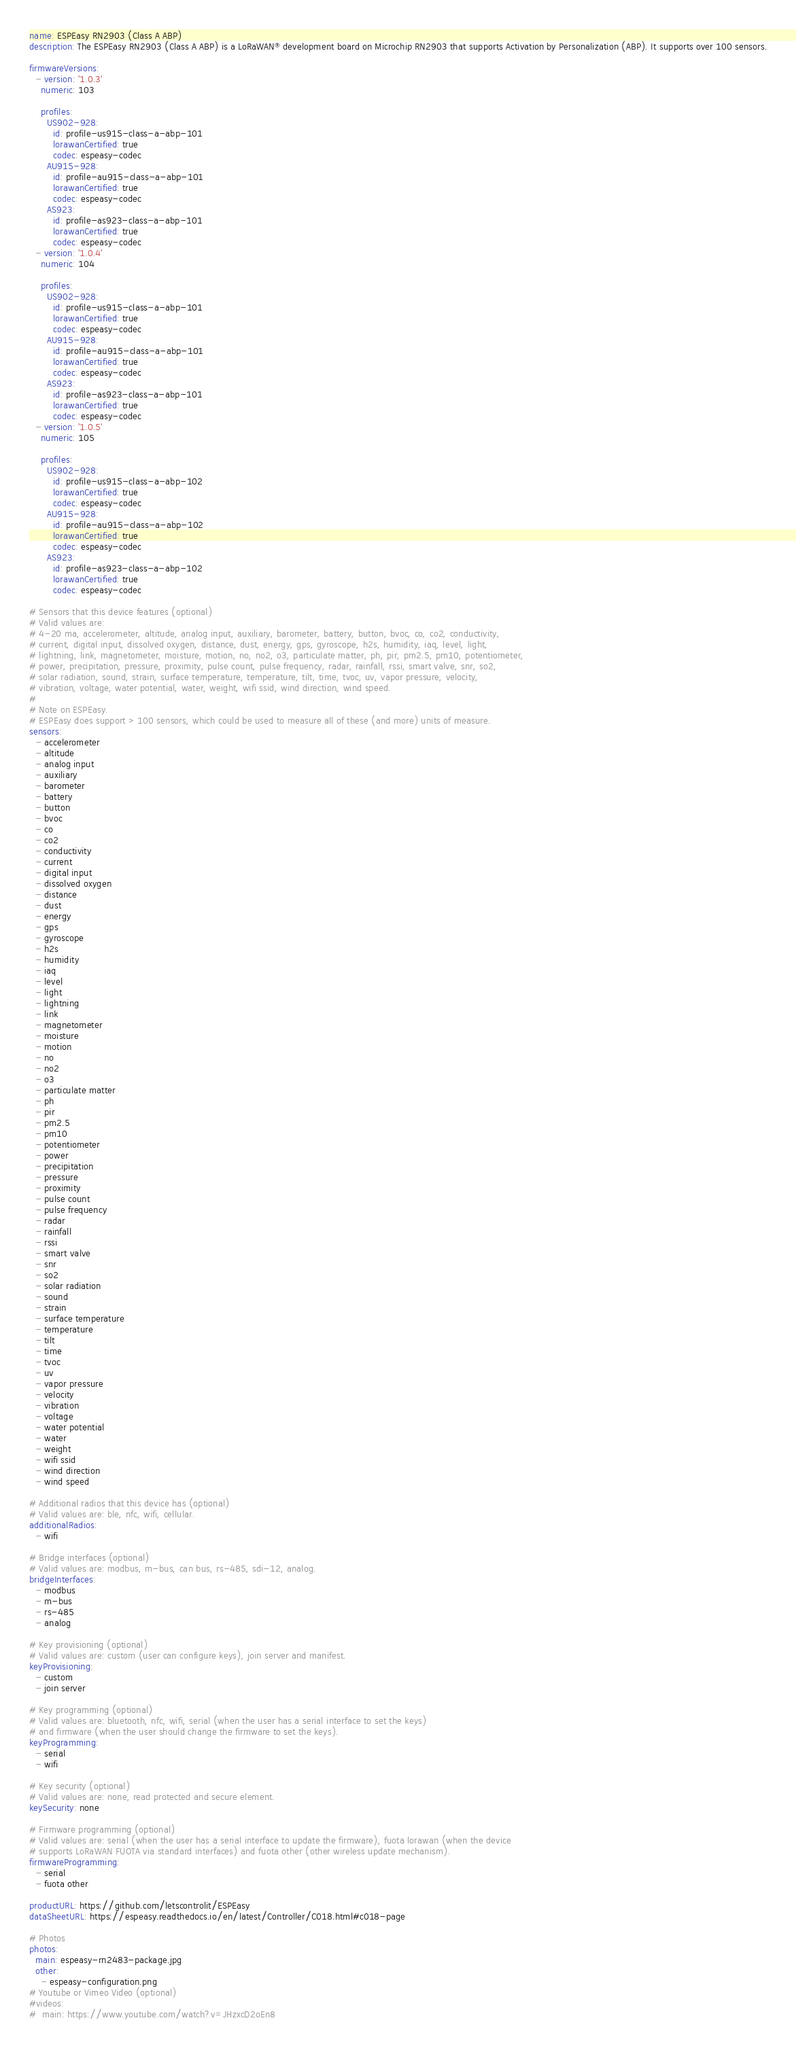Convert code to text. <code><loc_0><loc_0><loc_500><loc_500><_YAML_>name: ESPEasy RN2903 (Class A ABP)
description: The ESPEasy RN2903 (Class A ABP) is a LoRaWAN® development board on Microchip RN2903 that supports Activation by Personalization (ABP). It supports over 100 sensors.

firmwareVersions:
  - version: '1.0.3'
    numeric: 103

    profiles:
      US902-928:
        id: profile-us915-class-a-abp-101
        lorawanCertified: true
        codec: espeasy-codec
      AU915-928:
        id: profile-au915-class-a-abp-101
        lorawanCertified: true
        codec: espeasy-codec
      AS923:
        id: profile-as923-class-a-abp-101
        lorawanCertified: true
        codec: espeasy-codec
  - version: '1.0.4'
    numeric: 104

    profiles:
      US902-928:
        id: profile-us915-class-a-abp-101
        lorawanCertified: true
        codec: espeasy-codec
      AU915-928:
        id: profile-au915-class-a-abp-101
        lorawanCertified: true
        codec: espeasy-codec
      AS923:
        id: profile-as923-class-a-abp-101
        lorawanCertified: true
        codec: espeasy-codec
  - version: '1.0.5'
    numeric: 105

    profiles:
      US902-928:
        id: profile-us915-class-a-abp-102
        lorawanCertified: true
        codec: espeasy-codec
      AU915-928:
        id: profile-au915-class-a-abp-102
        lorawanCertified: true
        codec: espeasy-codec
      AS923:
        id: profile-as923-class-a-abp-102
        lorawanCertified: true
        codec: espeasy-codec

# Sensors that this device features (optional)
# Valid values are:
# 4-20 ma, accelerometer, altitude, analog input, auxiliary, barometer, battery, button, bvoc, co, co2, conductivity,
# current, digital input, dissolved oxygen, distance, dust, energy, gps, gyroscope, h2s, humidity, iaq, level, light,
# lightning, link, magnetometer, moisture, motion, no, no2, o3, particulate matter, ph, pir, pm2.5, pm10, potentiometer,
# power, precipitation, pressure, proximity, pulse count, pulse frequency, radar, rainfall, rssi, smart valve, snr, so2,
# solar radiation, sound, strain, surface temperature, temperature, tilt, time, tvoc, uv, vapor pressure, velocity,
# vibration, voltage, water potential, water, weight, wifi ssid, wind direction, wind speed.
#
# Note on ESPEasy.
# ESPEasy does support > 100 sensors, which could be used to measure all of these (and more) units of measure.
sensors:
  - accelerometer
  - altitude
  - analog input
  - auxiliary
  - barometer
  - battery
  - button
  - bvoc
  - co
  - co2
  - conductivity
  - current
  - digital input
  - dissolved oxygen
  - distance
  - dust
  - energy
  - gps
  - gyroscope
  - h2s
  - humidity
  - iaq
  - level
  - light
  - lightning
  - link
  - magnetometer
  - moisture
  - motion
  - no
  - no2
  - o3
  - particulate matter
  - ph
  - pir
  - pm2.5
  - pm10
  - potentiometer
  - power
  - precipitation
  - pressure
  - proximity
  - pulse count
  - pulse frequency
  - radar
  - rainfall
  - rssi
  - smart valve
  - snr
  - so2
  - solar radiation
  - sound
  - strain
  - surface temperature
  - temperature
  - tilt
  - time
  - tvoc
  - uv
  - vapor pressure
  - velocity
  - vibration
  - voltage
  - water potential
  - water
  - weight
  - wifi ssid
  - wind direction
  - wind speed

# Additional radios that this device has (optional)
# Valid values are: ble, nfc, wifi, cellular.
additionalRadios:
  - wifi

# Bridge interfaces (optional)
# Valid values are: modbus, m-bus, can bus, rs-485, sdi-12, analog.
bridgeInterfaces:
  - modbus
  - m-bus
  - rs-485
  - analog

# Key provisioning (optional)
# Valid values are: custom (user can configure keys), join server and manifest.
keyProvisioning:
  - custom
  - join server

# Key programming (optional)
# Valid values are: bluetooth, nfc, wifi, serial (when the user has a serial interface to set the keys)
# and firmware (when the user should change the firmware to set the keys).
keyProgramming:
  - serial
  - wifi

# Key security (optional)
# Valid values are: none, read protected and secure element.
keySecurity: none

# Firmware programming (optional)
# Valid values are: serial (when the user has a serial interface to update the firmware), fuota lorawan (when the device
# supports LoRaWAN FUOTA via standard interfaces) and fuota other (other wireless update mechanism).
firmwareProgramming:
  - serial
  - fuota other

productURL: https://github.com/letscontrolit/ESPEasy
dataSheetURL: https://espeasy.readthedocs.io/en/latest/Controller/C018.html#c018-page

# Photos
photos:
  main: espeasy-rn2483-package.jpg
  other:
    - espeasy-configuration.png
# Youtube or Vimeo Video (optional)
#videos:
#  main: https://www.youtube.com/watch?v=JHzxcD2oEn8
</code> 